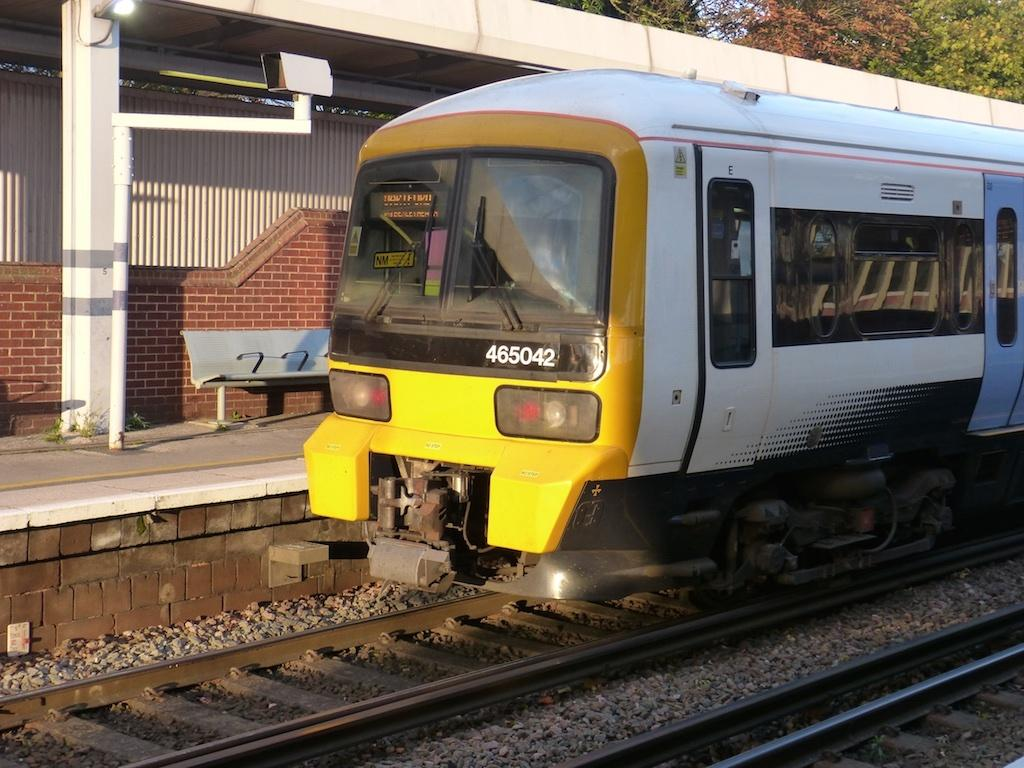What is the main subject of the image? The main subject of the image is a train. Where is the train located? The train is on a railway track. What can be seen in the background of the image? In the background of the image, there is sky, trees, plants, an electric light, benches, and a platform. Can you describe the setting of the image? The image appears to be set in a train station or platform area, with the train on the tracks and various background elements indicating a transportation hub. What type of amusement can be seen on the train in the image? There is no amusement present on the train in the image; it is a regular train on a railway track. What color is the underwear of the person sitting on the bench in the image? There are no people visible in the image, let alone their underwear, so this information cannot be determined. 